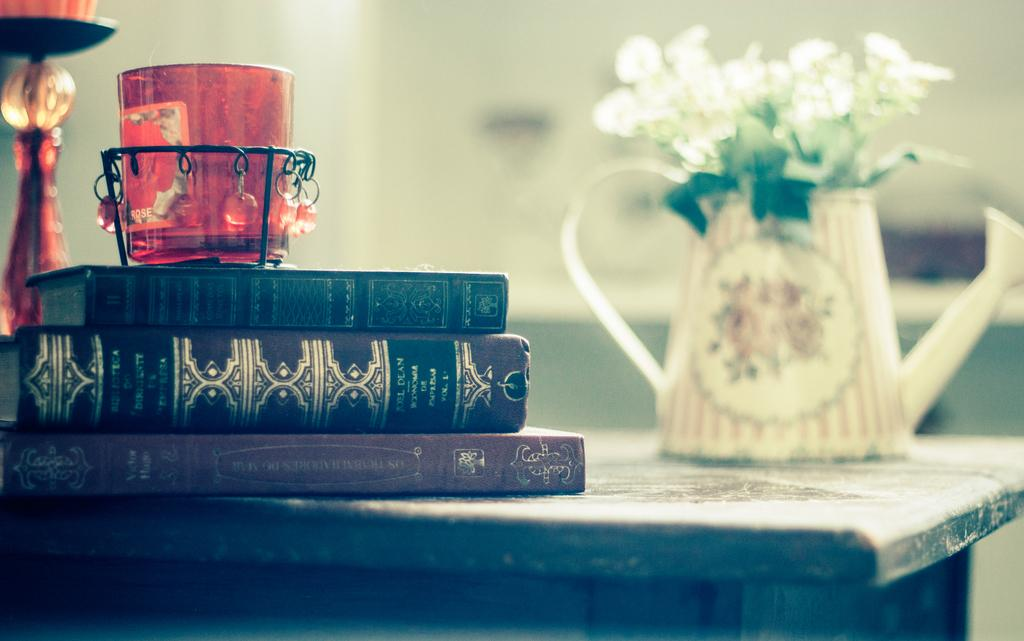What type of glass is present in the image? There is a decorative glass in the image. What other items can be seen on the table in the image? There are dairies, a candle stand, and a flower vase in the image. What is the purpose of the candle stand in the image? The candle stand is likely used for holding candles, although no candles are visible in the image. What is the flower vase used for? The flower vase is used for holding flowers, although no flowers are visible in the image. How many rats are sitting on the brick in the image? There is no brick or rat present in the image. 